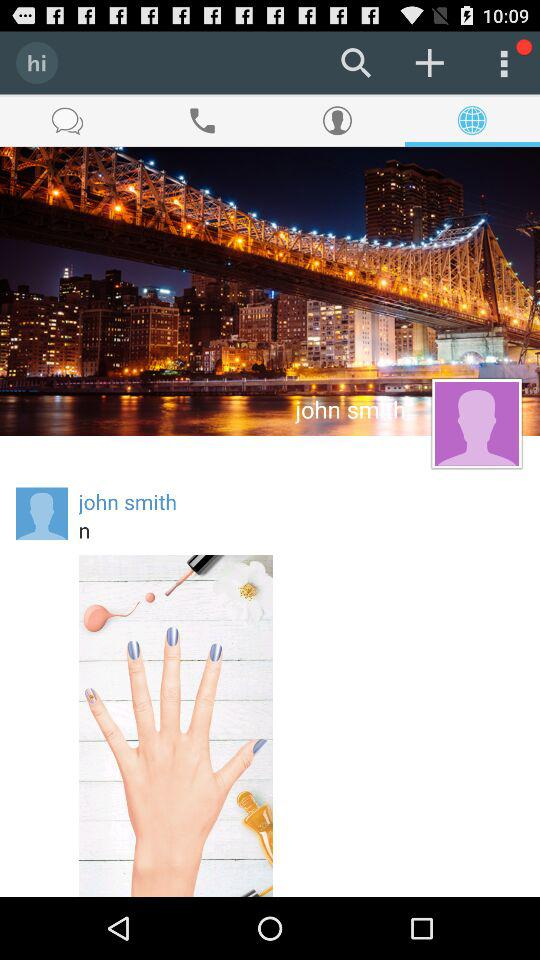What is the user's name? The user's name is John Smith. 